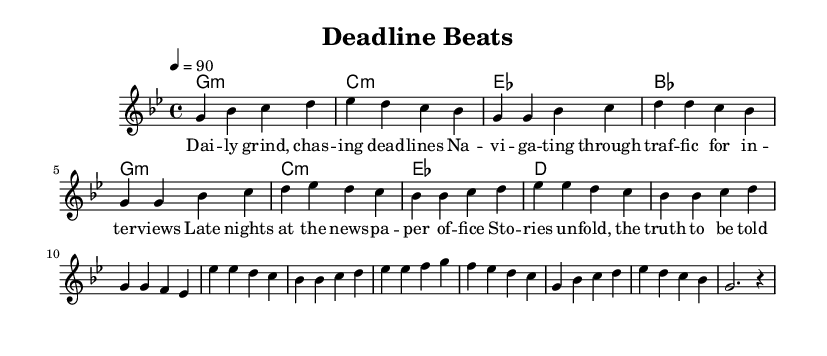What is the key signature of this music? The key signature is G minor, which contains two flats (B♭ and E♭). The presence of these flats is indicated at the beginning of the staff.
Answer: G minor What is the time signature of this composition? The time signature is indicated at the beginning of the score, showing that there are four beats in each measure, with a quarter note receiving one beat. This is denoted as 4/4.
Answer: 4/4 What is the tempo marking given in the score? The tempo marking indicates that the piece should be played at a speed of 90 beats per minute. This is shown at the top of the score as "4 = 90".
Answer: 90 How many measures are present in the melody? By counting the individual measures notated in the melody section of the sheet music, we can determine the total. The melody is divided into sections, and each section contains a specific number of measures that sum up to eight measures.
Answer: 8 What type of musical piece is this? This composition is characterized as a Hip Hop piece, evident from the lyrics and the rhythmic structure typical of the genre. The lyrics discuss the life of a newspaper journalist, which reflects Hip Hop's storytelling elements.
Answer: Hip Hop Which section follows the chorus in this composition? The score indicates a structure where after the chorus section, the music introduces a bridge. This is a common practice in song forms to provide variety and transition.
Answer: Bridge 